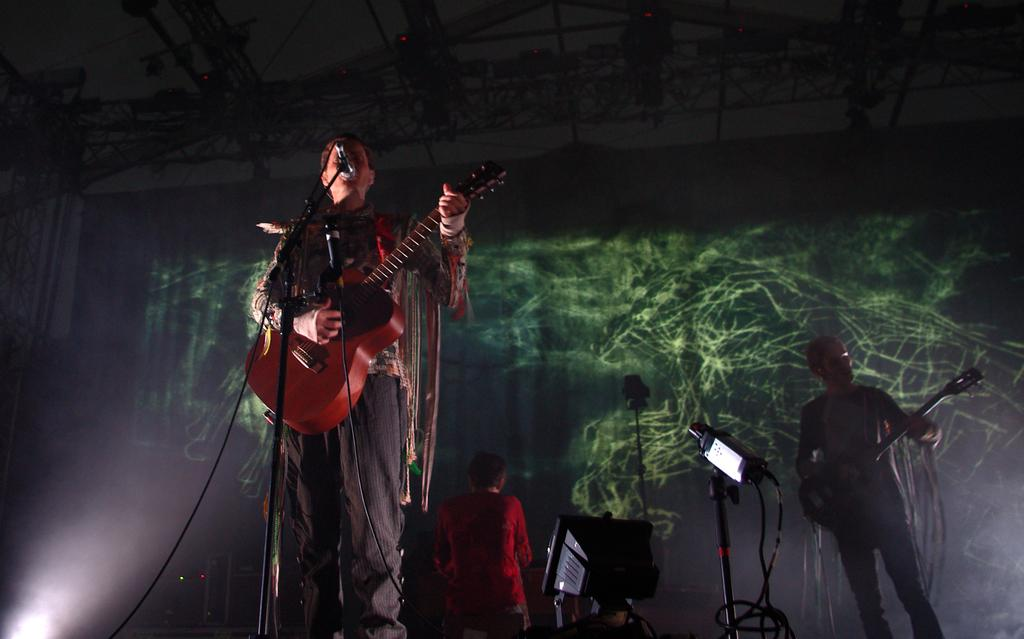What are the men in the image doing? The men are standing on stage. What are the men holding in the image? The men are holding a guitar. What are the men positioned in front of in the image? The men are in front of a microphone. How many geese are visible on stage with the men in the image? There are no geese present in the image; it features men standing on stage with a guitar and in front of a microphone. What type of rifle is the man holding in the image? There is no rifle present in the image; the men are holding a guitar. 